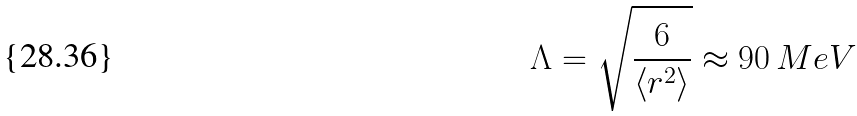<formula> <loc_0><loc_0><loc_500><loc_500>\Lambda = \sqrt { \frac { 6 } { \left \langle r ^ { 2 } \right \rangle } } \approx 9 0 \, M e V</formula> 